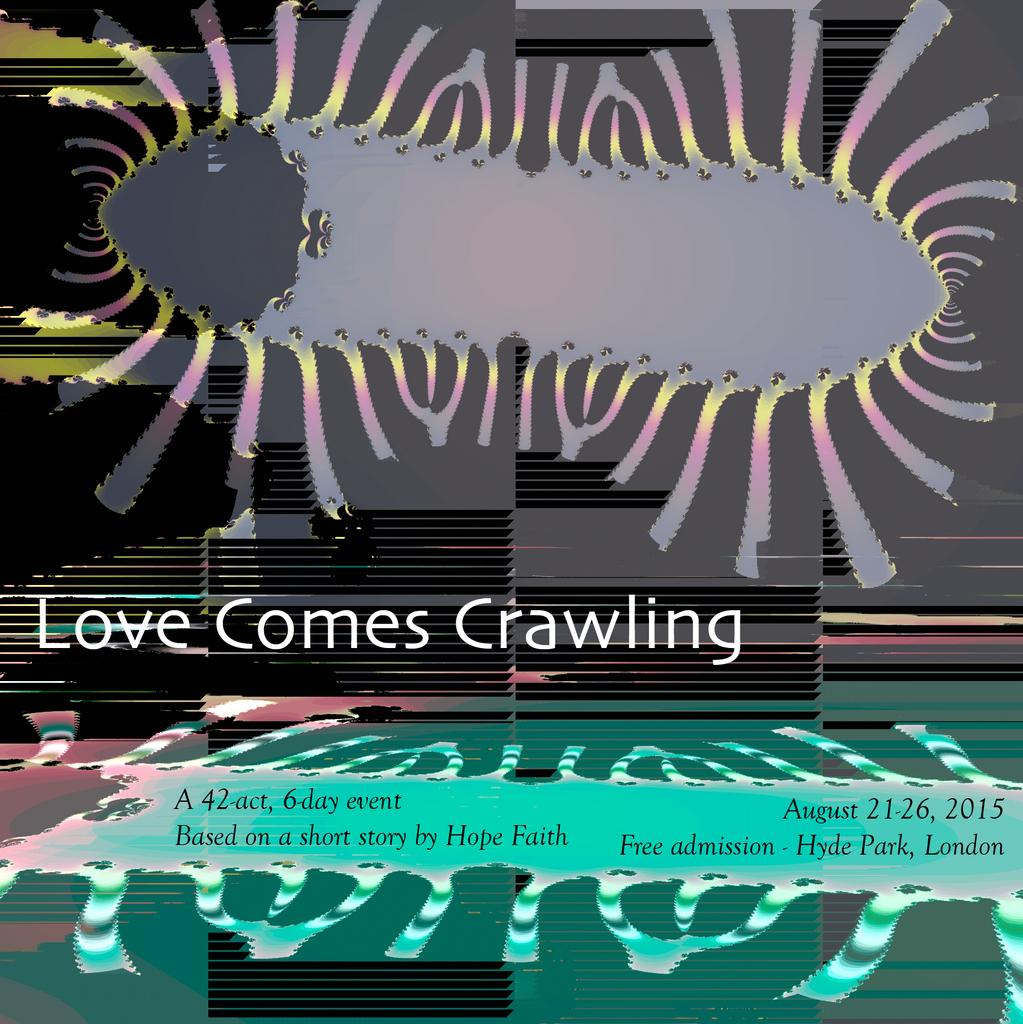<image>
Present a compact description of the photo's key features. A poster for an event in London called Love Comes Crawling. 